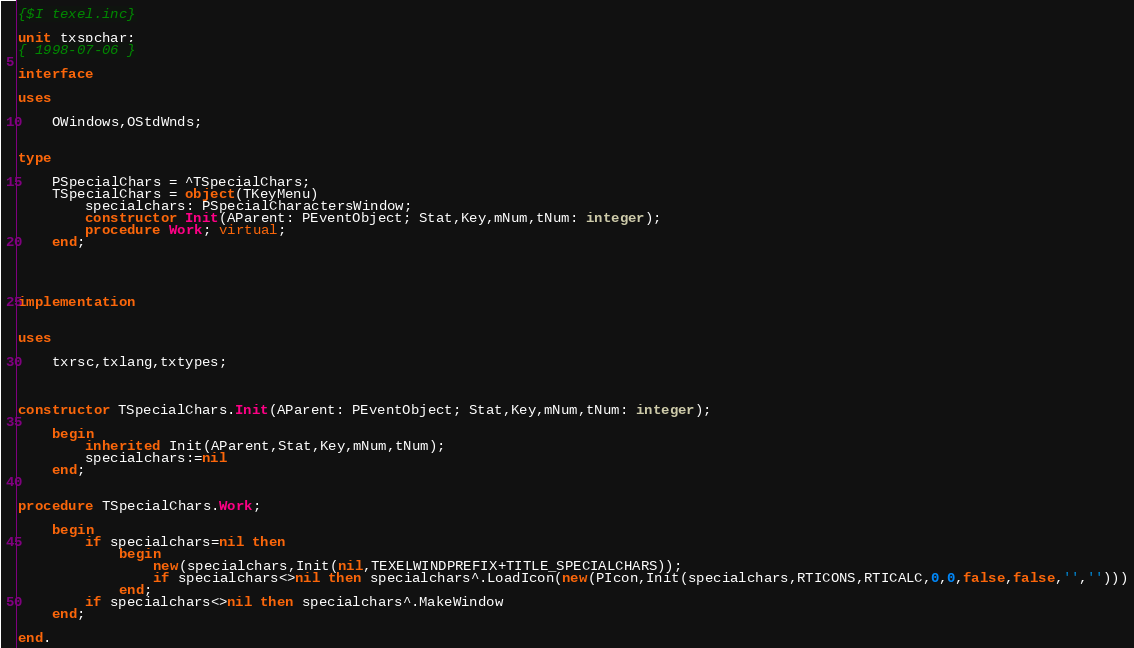<code> <loc_0><loc_0><loc_500><loc_500><_Pascal_>{$I texel.inc}

unit txspchar;
{ 1998-07-06 }

interface

uses

	OWindows,OStdWnds;


type

	PSpecialChars = ^TSpecialChars;
	TSpecialChars = object(TKeyMenu)
		specialchars: PSpecialCharactersWindow;
		constructor Init(AParent: PEventObject; Stat,Key,mNum,tNum: integer);
		procedure Work; virtual;
	end;




implementation


uses

	txrsc,txlang,txtypes;



constructor TSpecialChars.Init(AParent: PEventObject; Stat,Key,mNum,tNum: integer);

	begin
		inherited Init(AParent,Stat,Key,mNum,tNum);
		specialchars:=nil
	end;


procedure TSpecialChars.Work;

	begin
		if specialchars=nil then
			begin
				new(specialchars,Init(nil,TEXELWINDPREFIX+TITLE_SPECIALCHARS));
				if specialchars<>nil then specialchars^.LoadIcon(new(PIcon,Init(specialchars,RTICONS,RTICALC,0,0,false,false,'','')))
			end;
		if specialchars<>nil then specialchars^.MakeWindow
	end;

end.
</code> 